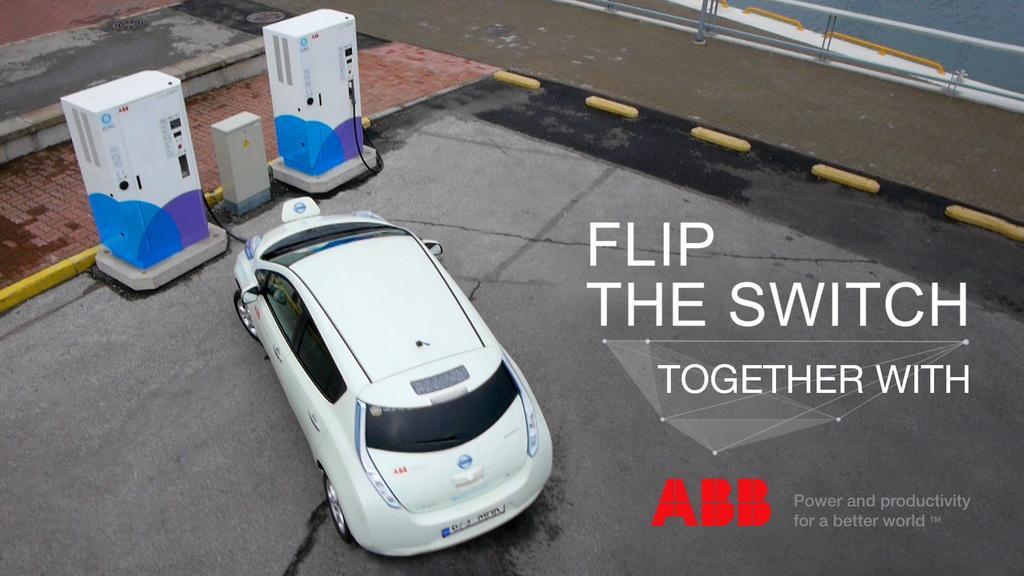How would you summarize this image in a sentence or two? In this image we can see a car, there are two fuel machines, also we can see the wall, and the text on the image, 